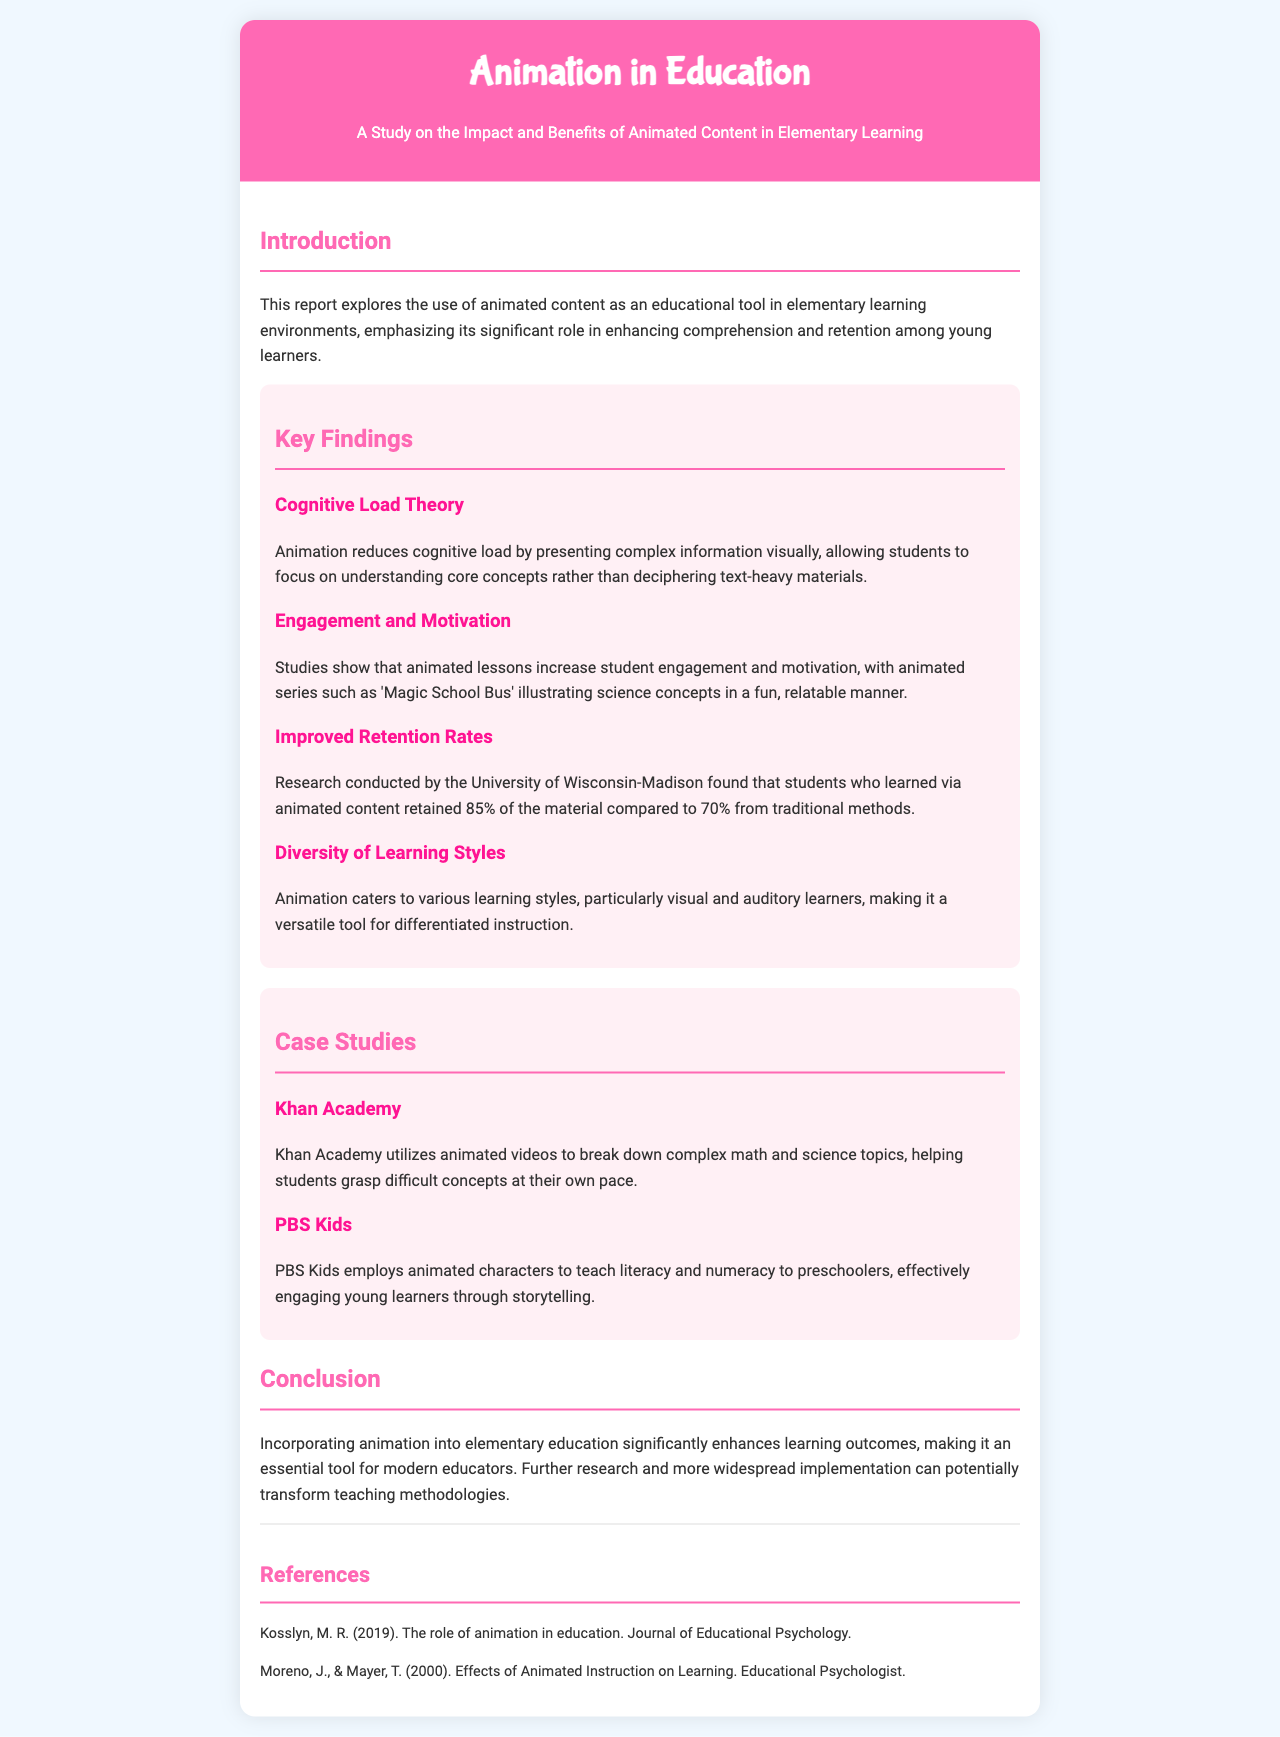What is the title of the report? The title is stated in the header of the document.
Answer: Animation in Education: A Study on the Impact and Benefits of Animated Content in Elementary Learning Which theory is mentioned that relates to cognitive load? The theory is specifically identified under the key findings section.
Answer: Cognitive Load Theory What percentage of material did students retain when learning via animated content according to the report? The retention rates are compared in the key findings section.
Answer: 85% Which animated series is referenced to illustrate science concepts? The series name is given as an example in the key findings section.
Answer: Magic School Bus What tool does Khan Academy use to help students learn difficult concepts? The type of content Khan Academy uses is indicated in the case studies section.
Answer: Animated videos Who are the authors of the paper referenced in the document? The authors' names are listed in the references section.
Answer: Kosslyn, M. R. and Moreno, J. & Mayer, T What educational content does PBS Kids utilize for teaching? The specific type of content used by PBS Kids is mentioned in the case studies.
Answer: Animated characters How does animation cater to learning styles? The answer is found in the key findings part of the report, discussing learning styles.
Answer: Visual and auditory learners 